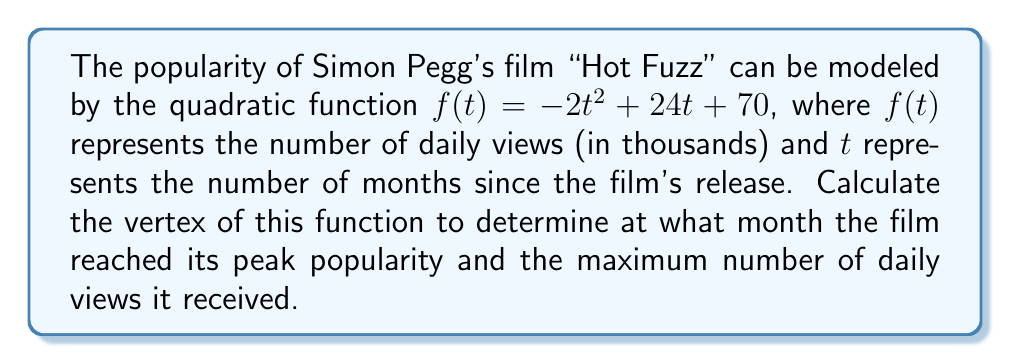What is the answer to this math problem? To find the vertex of a quadratic function in the form $f(t) = at^2 + bt + c$, we can use the formula:

$t = -\frac{b}{2a}$

Where $t$ is the $t$-coordinate of the vertex.

1) In this case, $a = -2$, $b = 24$, and $c = 70$.

2) Substituting these values into the formula:

   $t = -\frac{24}{2(-2)} = -\frac{24}{-4} = 6$

3) To find the $y$-coordinate (peak daily views), we substitute $t = 6$ into the original function:

   $f(6) = -2(6)^2 + 24(6) + 70$
   $    = -2(36) + 144 + 70$
   $    = -72 + 144 + 70$
   $    = 142$

4) Therefore, the vertex is (6, 142).

This means the film reached its peak popularity 6 months after release, with a maximum of 142,000 daily views.
Answer: (6, 142) 